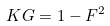Convert formula to latex. <formula><loc_0><loc_0><loc_500><loc_500>K G = 1 - F ^ { 2 }</formula> 